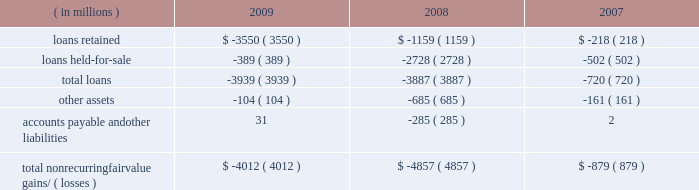Notes to consolidated financial statements jpmorgan chase & co./2009 annual report 168 nonrecurring fair value changes the table presents the total change in value of financial instruments for which a fair value adjustment has been included in the consolidated statements of income for the years ended december 31 , 2009 , 2008 and 2007 , related to financial instru- ments held at these dates .
Year ended december 31 .
Accounts payable and other liabilities 31 ( 285 ) 2 total nonrecurring fair value gains/ ( losses ) $ ( 4012 ) $ ( 4857 ) $ ( 879 ) in the above table , loans predominantly include : ( 1 ) write-downs of delinquent mortgage and home equity loans where impairment is based on the fair value of the underlying collateral ; and ( 2 ) the change in fair value for leveraged lending loans carried on the consolidated balance sheets at the lower of cost or fair value .
Accounts payable and other liabilities predominantly include the change in fair value for unfunded lending-related commitments within the leveraged lending portfolio .
Level 3 analysis level 3 assets ( including assets measured at fair value on a nonre- curring basis ) were 6% ( 6 % ) of total firm assets at both december 31 , 2009 and 2008 .
Level 3 assets were $ 130.4 billion at december 31 , 2009 , reflecting a decrease of $ 7.3 billion in 2009 , due to the following : 2022 a net decrease of $ 6.3 billion in gross derivative receivables , predominantly driven by the tightening of credit spreads .
Offset- ting a portion of the decrease were net transfers into level 3 dur- ing the year , most notably a transfer into level 3 of $ 41.3 billion of structured credit derivative receivables , and a transfer out of level 3 of $ 17.7 billion of single-name cds on abs .
The fair value of the receivables transferred into level 3 during the year was $ 22.1 billion at december 31 , 2009 .
The fair value of struc- tured credit derivative payables with a similar underlying risk profile to the previously noted receivables , that are also classified in level 3 , was $ 12.5 billion at december 31 , 2009 .
These de- rivatives payables offset the receivables , as they are modeled and valued the same way with the same parameters and inputs as the assets .
2022 a net decrease of $ 3.5 billion in loans , predominantly driven by sales of leveraged loans and transfers of similar loans to level 2 , due to increased price transparency for such assets .
Leveraged loans are typically classified as held-for-sale and measured at the lower of cost or fair value and , therefore , included in the nonre- curring fair value assets .
2022 a net decrease of $ 6.3 billion in trading assets 2013 debt and equity instruments , primarily in loans and residential- and commercial- mbs , principally driven by sales and markdowns , and by sales and unwinds of structured transactions with hedge funds .
The declines were partially offset by a transfer from level 2 to level 3 of certain structured notes reflecting lower liquidity and less pricing ob- servability , and also increases in the fair value of other abs .
2022 a net increase of $ 6.1 billion in msrs , due to increases in the fair value of the asset , related primarily to market interest rate and other changes affecting the firm's estimate of future pre- payments , as well as sales in rfs of originated loans for which servicing rights were retained .
These increases were offset par- tially by servicing portfolio runoff .
2022 a net increase of $ 1.9 billion in accrued interest and accounts receivable related to increases in subordinated retained interests from the firm 2019s credit card securitization activities .
Gains and losses gains and losses included in the tables for 2009 and 2008 included : 2022 $ 11.4 billion of net losses on derivatives , primarily related to the tightening of credit spreads .
2022 net losses on trading 2013debt and equity instruments of $ 671 million , consisting of $ 2.1 billion of losses , primarily related to residential and commercial loans and mbs , principally driven by markdowns and sales , partially offset by gains of $ 1.4 billion , reflecting increases in the fair value of other abs .
( for a further discussion of the gains and losses on mortgage-related expo- sures , inclusive of risk management activities , see the 201cmort- gage-related exposures carried at fair value 201d discussion below. ) 2022 $ 5.8 billion of gains on msrs .
2022 $ 1.4 billion of losses related to structured note liabilities , pre- dominantly due to volatility in the equity markets .
2022 losses on trading-debt and equity instruments of approximately $ 12.8 billion , principally from mortgage-related transactions and auction-rate securities .
2022 losses of $ 6.9 billion on msrs .
2022 losses of approximately $ 3.9 billion on leveraged loans .
2022 net gains of $ 4.6 billion related to derivatives , principally due to changes in credit spreads and rate curves .
2022 gains of $ 4.5 billion related to structured notes , principally due to significant volatility in the fixed income , commodities and eq- uity markets .
2022 private equity losses of $ 638 million .
For further information on changes in the fair value of the msrs , see note 17 on pages 223 2013224 of this annual report. .
What was the increase observed in the accounts payable and other liabilities during the years 2008-2009 , in millions? 
Rationale: it is the difference between those values during 2008 and 2009 .
Computations: (31 - -285)
Answer: 316.0. 